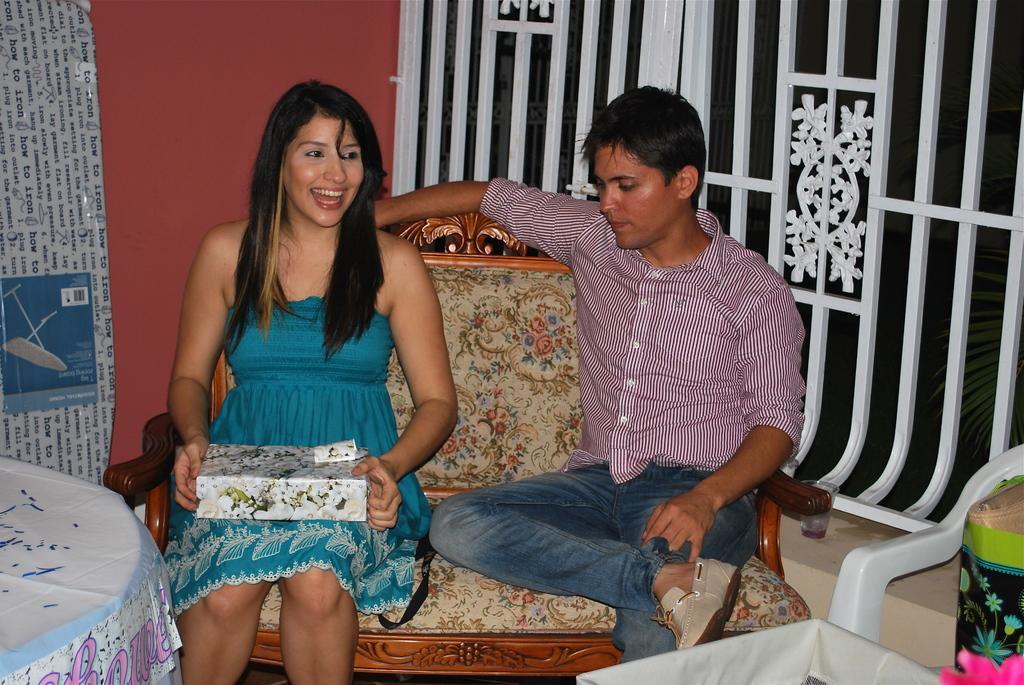In one or two sentences, can you explain what this image depicts? This image consists of two persons sitting in a sofa. The woman is wearing blue dress. To the right, the man is wearing blue jeans and pink shirt. To the left, there is a table covered with a white cloth. In the background, there is a railing along with wall. To the right, there is a chair. 